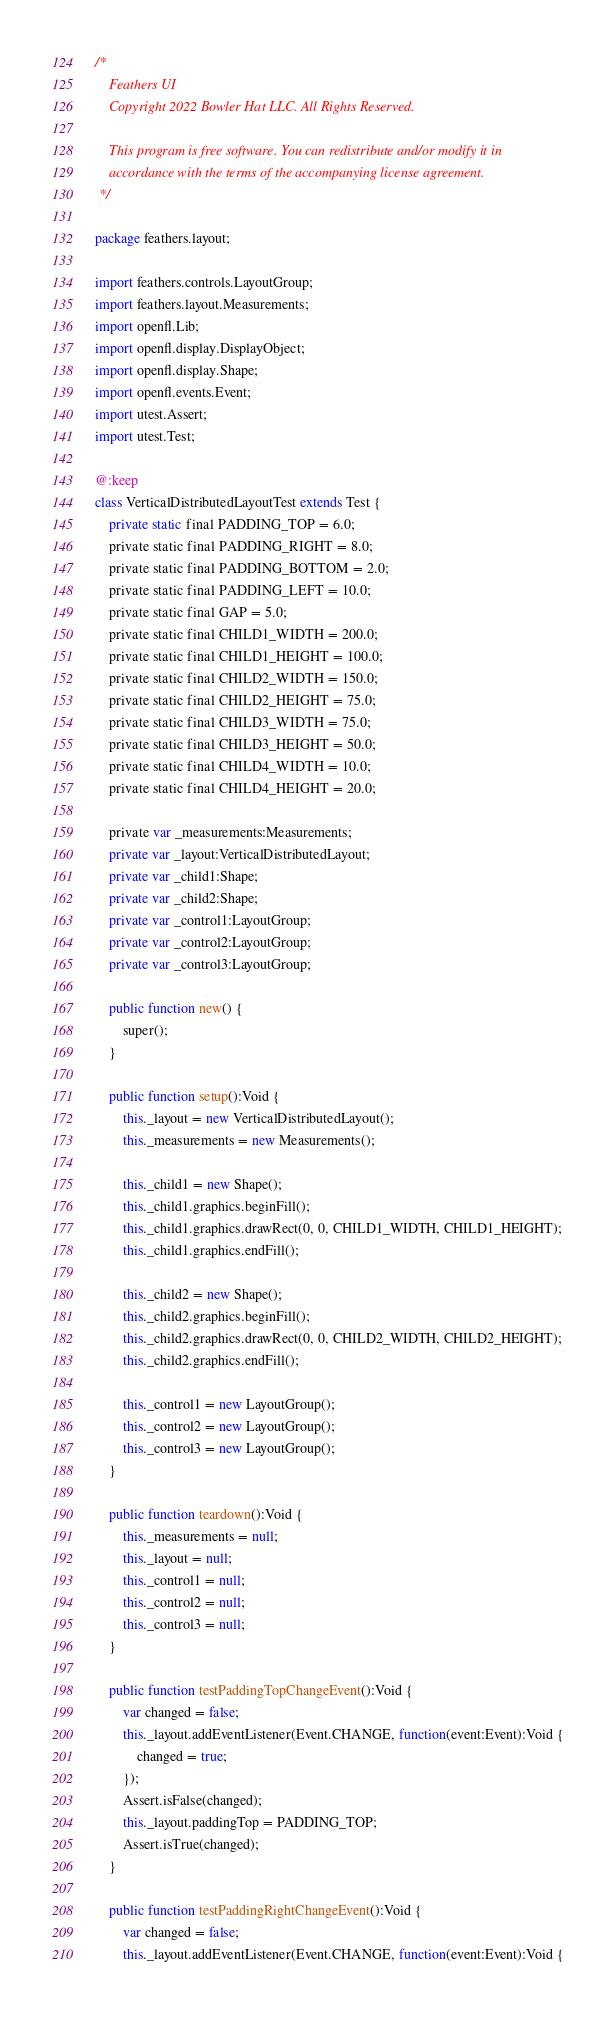Convert code to text. <code><loc_0><loc_0><loc_500><loc_500><_Haxe_>/*
	Feathers UI
	Copyright 2022 Bowler Hat LLC. All Rights Reserved.

	This program is free software. You can redistribute and/or modify it in
	accordance with the terms of the accompanying license agreement.
 */

package feathers.layout;

import feathers.controls.LayoutGroup;
import feathers.layout.Measurements;
import openfl.Lib;
import openfl.display.DisplayObject;
import openfl.display.Shape;
import openfl.events.Event;
import utest.Assert;
import utest.Test;

@:keep
class VerticalDistributedLayoutTest extends Test {
	private static final PADDING_TOP = 6.0;
	private static final PADDING_RIGHT = 8.0;
	private static final PADDING_BOTTOM = 2.0;
	private static final PADDING_LEFT = 10.0;
	private static final GAP = 5.0;
	private static final CHILD1_WIDTH = 200.0;
	private static final CHILD1_HEIGHT = 100.0;
	private static final CHILD2_WIDTH = 150.0;
	private static final CHILD2_HEIGHT = 75.0;
	private static final CHILD3_WIDTH = 75.0;
	private static final CHILD3_HEIGHT = 50.0;
	private static final CHILD4_WIDTH = 10.0;
	private static final CHILD4_HEIGHT = 20.0;

	private var _measurements:Measurements;
	private var _layout:VerticalDistributedLayout;
	private var _child1:Shape;
	private var _child2:Shape;
	private var _control1:LayoutGroup;
	private var _control2:LayoutGroup;
	private var _control3:LayoutGroup;

	public function new() {
		super();
	}

	public function setup():Void {
		this._layout = new VerticalDistributedLayout();
		this._measurements = new Measurements();

		this._child1 = new Shape();
		this._child1.graphics.beginFill();
		this._child1.graphics.drawRect(0, 0, CHILD1_WIDTH, CHILD1_HEIGHT);
		this._child1.graphics.endFill();

		this._child2 = new Shape();
		this._child2.graphics.beginFill();
		this._child2.graphics.drawRect(0, 0, CHILD2_WIDTH, CHILD2_HEIGHT);
		this._child2.graphics.endFill();

		this._control1 = new LayoutGroup();
		this._control2 = new LayoutGroup();
		this._control3 = new LayoutGroup();
	}

	public function teardown():Void {
		this._measurements = null;
		this._layout = null;
		this._control1 = null;
		this._control2 = null;
		this._control3 = null;
	}

	public function testPaddingTopChangeEvent():Void {
		var changed = false;
		this._layout.addEventListener(Event.CHANGE, function(event:Event):Void {
			changed = true;
		});
		Assert.isFalse(changed);
		this._layout.paddingTop = PADDING_TOP;
		Assert.isTrue(changed);
	}

	public function testPaddingRightChangeEvent():Void {
		var changed = false;
		this._layout.addEventListener(Event.CHANGE, function(event:Event):Void {</code> 